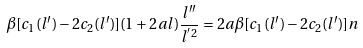<formula> <loc_0><loc_0><loc_500><loc_500>\beta [ c _ { 1 } ( l ^ { \prime } ) - 2 c _ { 2 } ( l ^ { \prime } ) ] ( 1 + 2 a l ) \frac { l ^ { \prime \prime } } { l ^ { ^ { \prime } 2 } } = 2 a \beta [ c _ { 1 } ( l ^ { \prime } ) - 2 c _ { 2 } ( l ^ { \prime } ) ] n</formula> 